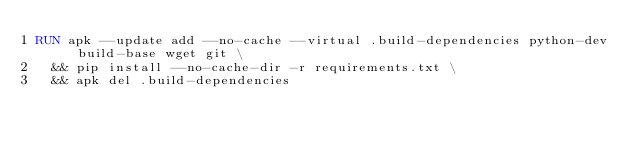Convert code to text. <code><loc_0><loc_0><loc_500><loc_500><_Dockerfile_>RUN apk --update add --no-cache --virtual .build-dependencies python-dev build-base wget git \
  && pip install --no-cache-dir -r requirements.txt \
  && apk del .build-dependencies
</code> 